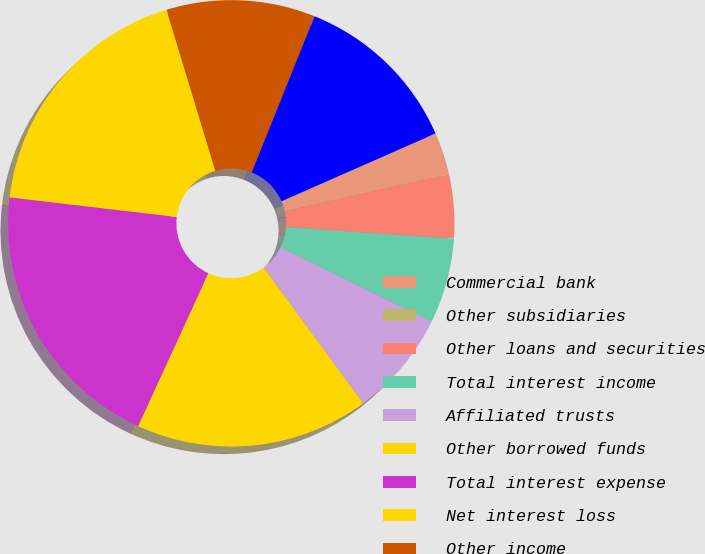Convert chart. <chart><loc_0><loc_0><loc_500><loc_500><pie_chart><fcel>Commercial bank<fcel>Other subsidiaries<fcel>Other loans and securities<fcel>Total interest income<fcel>Affiliated trusts<fcel>Other borrowed funds<fcel>Total interest expense<fcel>Net interest loss<fcel>Other income<fcel>Salaries and employee benefits<nl><fcel>3.08%<fcel>0.0%<fcel>4.62%<fcel>6.15%<fcel>7.69%<fcel>16.92%<fcel>20.0%<fcel>18.46%<fcel>10.77%<fcel>12.31%<nl></chart> 